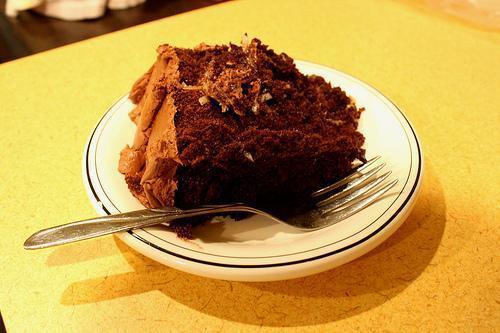How many forks are in the picture?
Give a very brief answer. 1. 